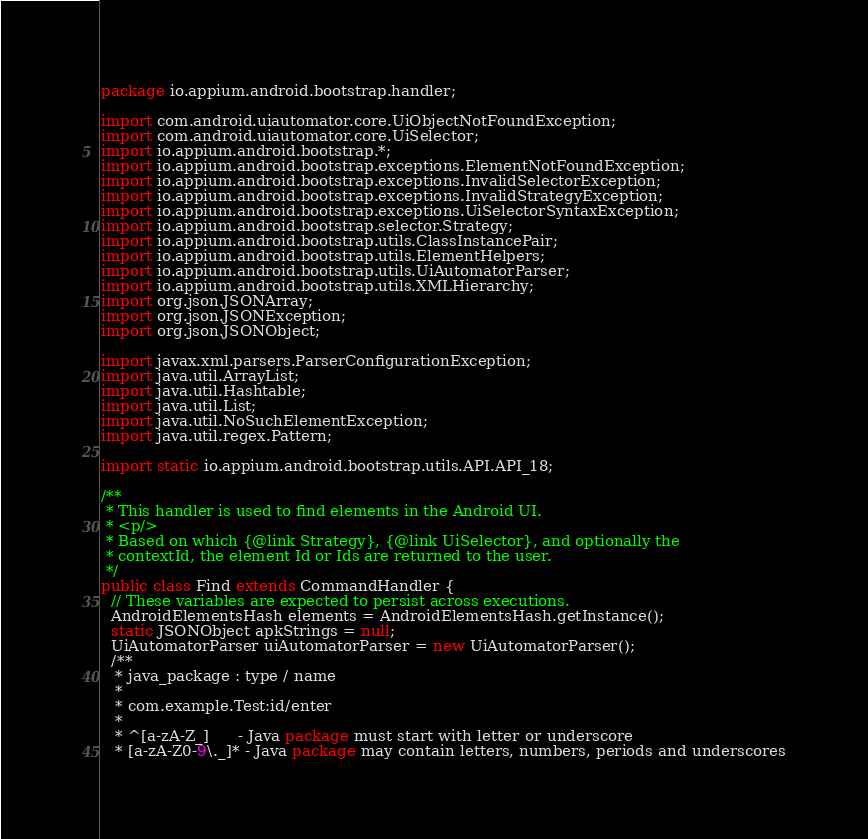<code> <loc_0><loc_0><loc_500><loc_500><_Java_>package io.appium.android.bootstrap.handler;

import com.android.uiautomator.core.UiObjectNotFoundException;
import com.android.uiautomator.core.UiSelector;
import io.appium.android.bootstrap.*;
import io.appium.android.bootstrap.exceptions.ElementNotFoundException;
import io.appium.android.bootstrap.exceptions.InvalidSelectorException;
import io.appium.android.bootstrap.exceptions.InvalidStrategyException;
import io.appium.android.bootstrap.exceptions.UiSelectorSyntaxException;
import io.appium.android.bootstrap.selector.Strategy;
import io.appium.android.bootstrap.utils.ClassInstancePair;
import io.appium.android.bootstrap.utils.ElementHelpers;
import io.appium.android.bootstrap.utils.UiAutomatorParser;
import io.appium.android.bootstrap.utils.XMLHierarchy;
import org.json.JSONArray;
import org.json.JSONException;
import org.json.JSONObject;

import javax.xml.parsers.ParserConfigurationException;
import java.util.ArrayList;
import java.util.Hashtable;
import java.util.List;
import java.util.NoSuchElementException;
import java.util.regex.Pattern;

import static io.appium.android.bootstrap.utils.API.API_18;

/**
 * This handler is used to find elements in the Android UI.
 * <p/>
 * Based on which {@link Strategy}, {@link UiSelector}, and optionally the
 * contextId, the element Id or Ids are returned to the user.
 */
public class Find extends CommandHandler {
  // These variables are expected to persist across executions.
  AndroidElementsHash elements = AndroidElementsHash.getInstance();
  static JSONObject apkStrings = null;
  UiAutomatorParser uiAutomatorParser = new UiAutomatorParser();
  /**
   * java_package : type / name
   *
   * com.example.Test:id/enter
   *
   * ^[a-zA-Z_]      - Java package must start with letter or underscore
   * [a-zA-Z0-9\._]* - Java package may contain letters, numbers, periods and underscores</code> 